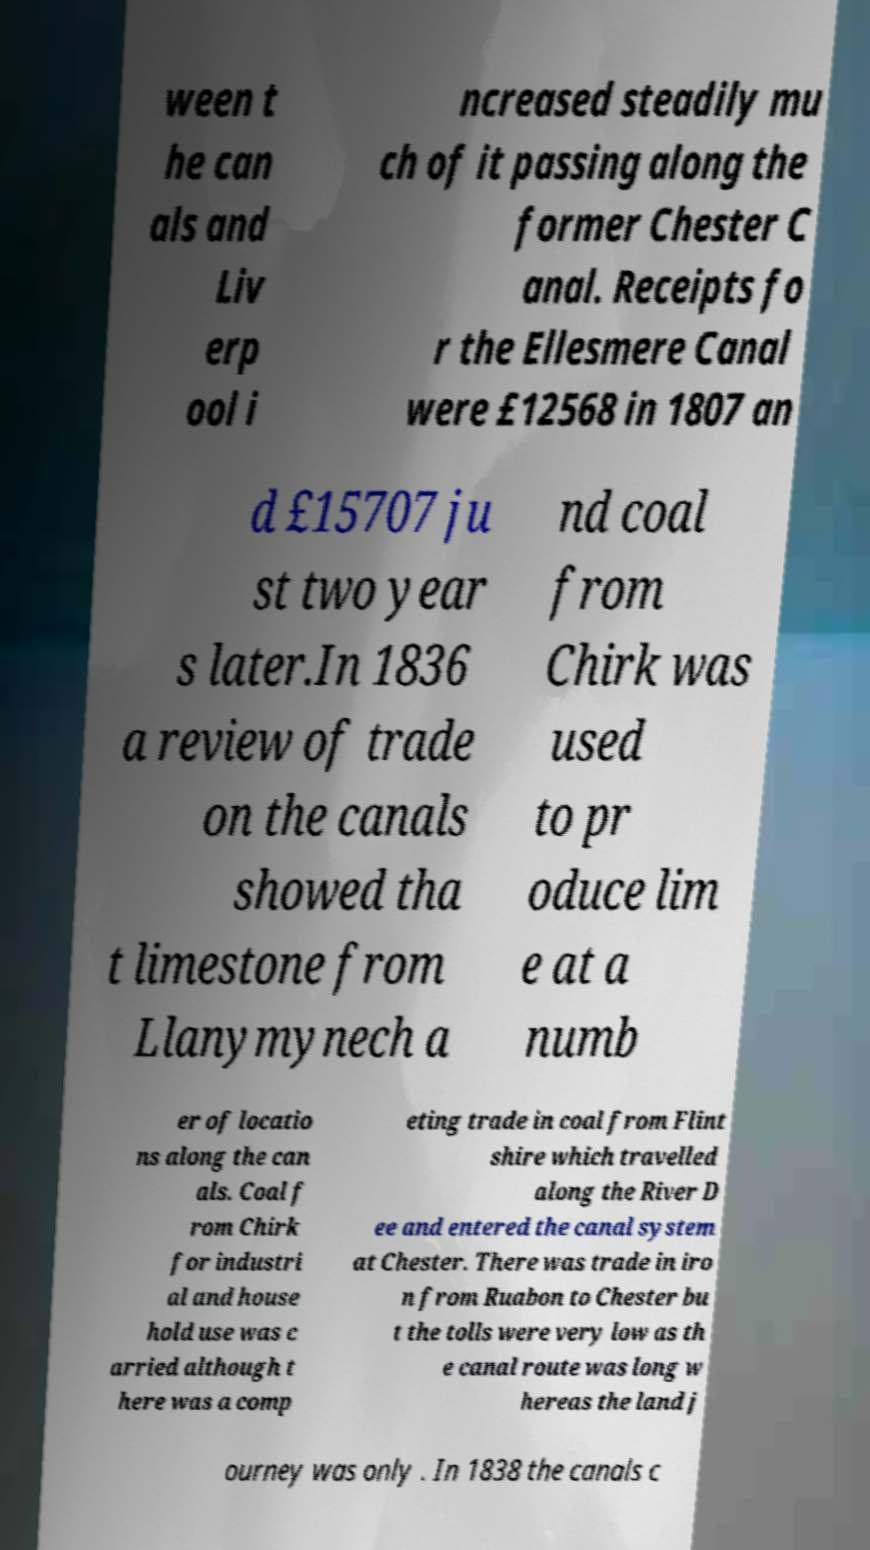There's text embedded in this image that I need extracted. Can you transcribe it verbatim? ween t he can als and Liv erp ool i ncreased steadily mu ch of it passing along the former Chester C anal. Receipts fo r the Ellesmere Canal were £12568 in 1807 an d £15707 ju st two year s later.In 1836 a review of trade on the canals showed tha t limestone from Llanymynech a nd coal from Chirk was used to pr oduce lim e at a numb er of locatio ns along the can als. Coal f rom Chirk for industri al and house hold use was c arried although t here was a comp eting trade in coal from Flint shire which travelled along the River D ee and entered the canal system at Chester. There was trade in iro n from Ruabon to Chester bu t the tolls were very low as th e canal route was long w hereas the land j ourney was only . In 1838 the canals c 